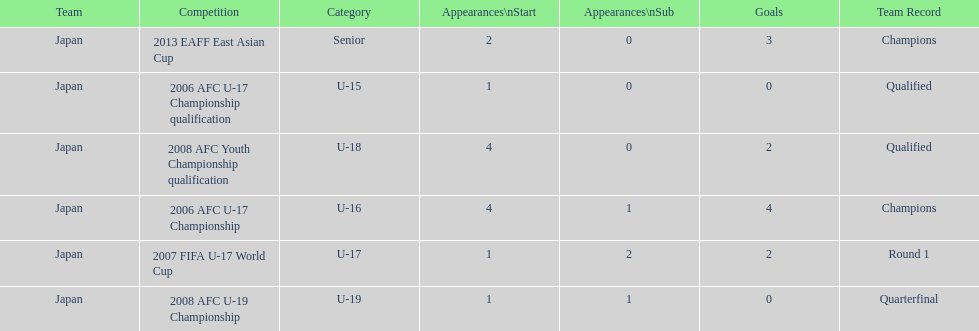Yoichiro kakitani scored above 2 goals in how many major competitions? 2. 